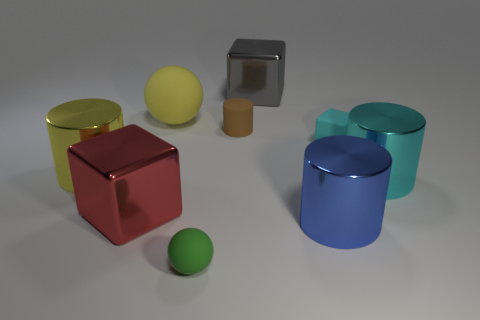How many cubes are the same material as the large blue thing?
Offer a terse response. 2. Are any large blue things visible?
Your answer should be compact. Yes. How big is the shiny cylinder to the left of the big blue thing?
Your answer should be very brief. Large. What number of metallic blocks are the same color as the large matte object?
Your answer should be very brief. 0. What number of cubes are either yellow objects or yellow rubber things?
Your response must be concise. 0. There is a large metal thing that is to the left of the tiny green object and to the right of the yellow metallic cylinder; what is its shape?
Make the answer very short. Cube. Is there a blue metallic cylinder that has the same size as the blue thing?
Give a very brief answer. No. How many objects are either cyan metallic cylinders that are on the right side of the tiny cube or big things?
Offer a very short reply. 6. Does the tiny cylinder have the same material as the yellow object that is in front of the big rubber ball?
Offer a terse response. No. How many other objects are the same shape as the large cyan thing?
Make the answer very short. 3. 